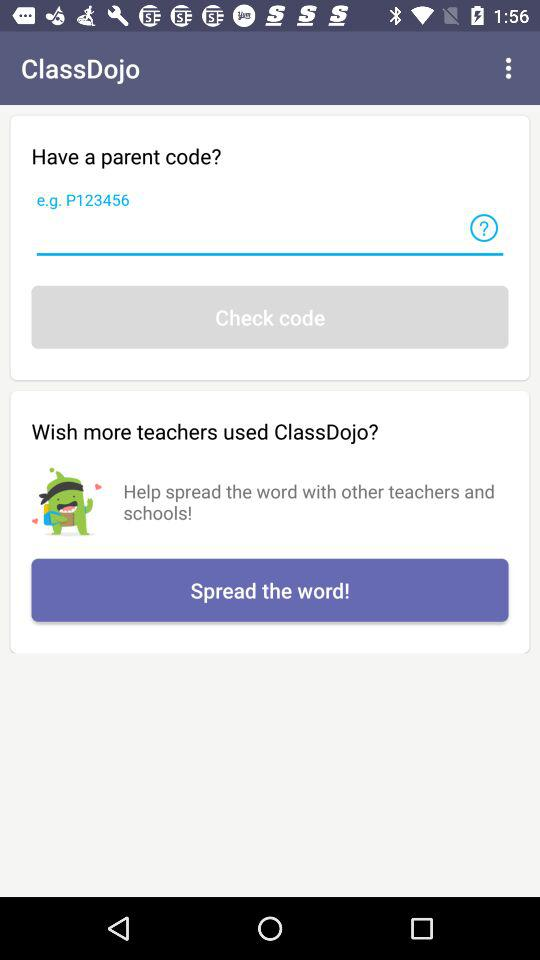What is the name of the application? The name of the application is "ClassDojo". 